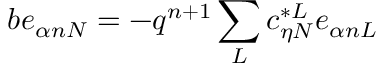Convert formula to latex. <formula><loc_0><loc_0><loc_500><loc_500>b e _ { \alpha n N } = - q ^ { n + 1 } \sum _ { L } c _ { \eta N } ^ { * L } e _ { \alpha n L }</formula> 